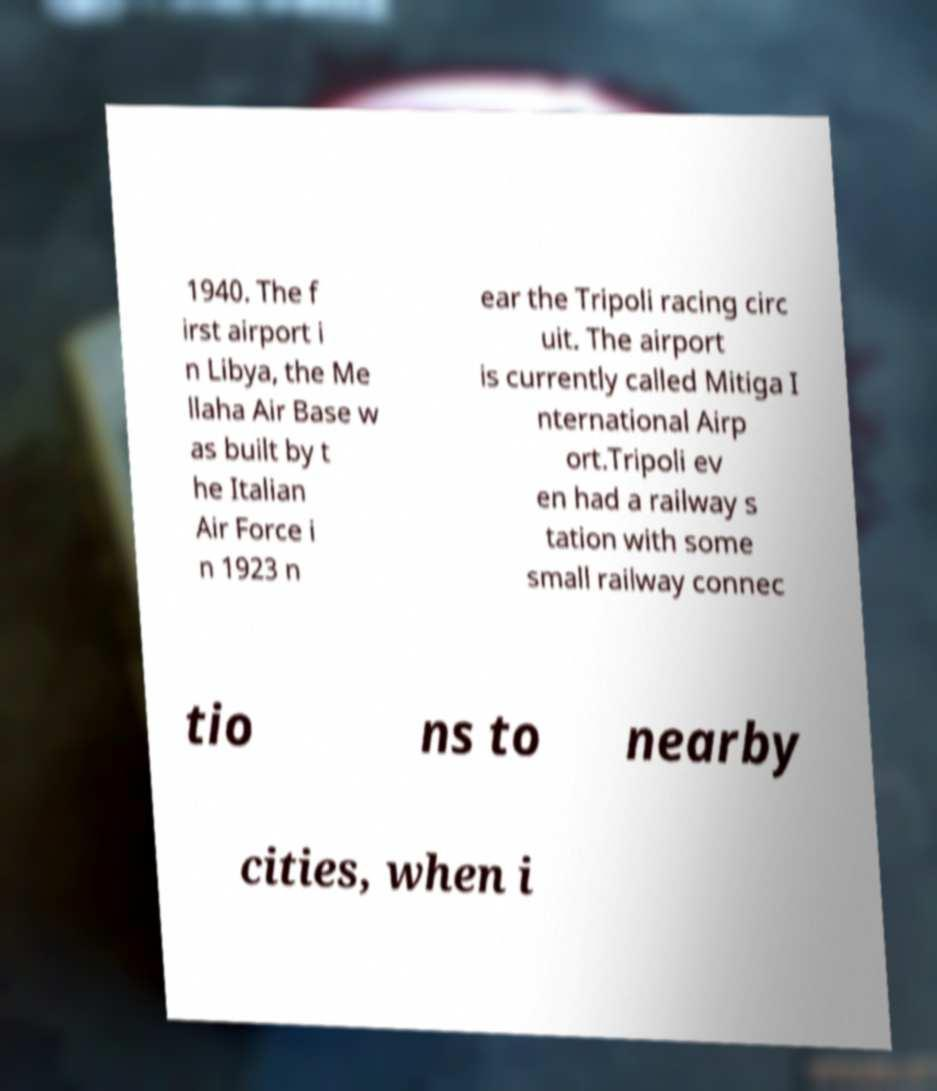What messages or text are displayed in this image? I need them in a readable, typed format. 1940. The f irst airport i n Libya, the Me llaha Air Base w as built by t he Italian Air Force i n 1923 n ear the Tripoli racing circ uit. The airport is currently called Mitiga I nternational Airp ort.Tripoli ev en had a railway s tation with some small railway connec tio ns to nearby cities, when i 